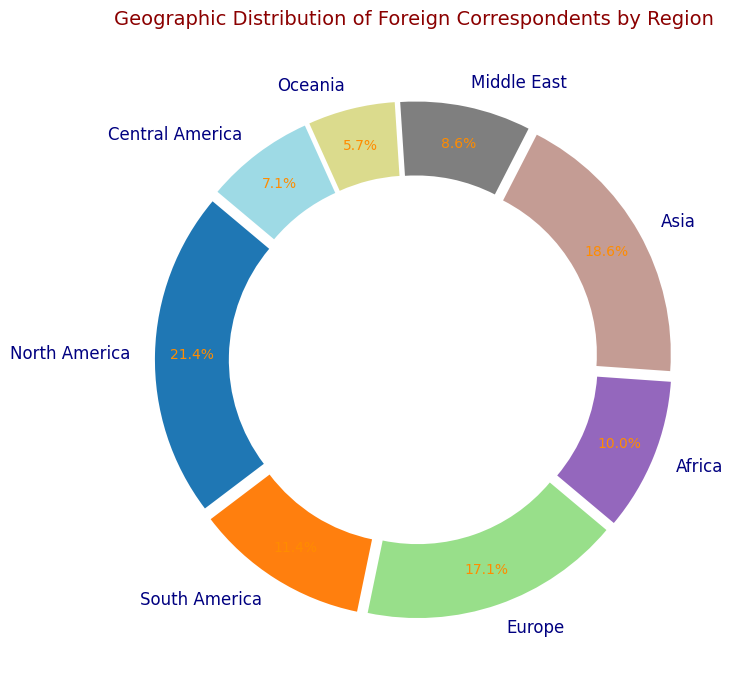What percentage of foreign correspondents are based in Asia? To determine the percentage, look for the label corresponding to Asia on the figure. Observe the percentage value displayed next to it.
Answer: 18.2% How many more foreign correspondents are there in North America compared to Africa? Find the numerical values of North America (150) and Africa (70) from the labels and subtract the number of correspondents in Africa from those in North America: 150 - 70 = 80.
Answer: 80 Which region has the lowest number of foreign correspondents? Identify the region with the smallest percentage or the smallest segment in the ring chart. Look for Oceania, which has the smallest share.
Answer: Oceania What is the combined percentage of foreign correspondents in Europe, Asia, and North America? Add the given percentages for Europe, Asia, and North America directly from the figure. Europe is 16.7%, Asia is 18.2%, and North America is 21.7%. The sum is 16.7% + 18.2% + 21.7% = 56.6%.
Answer: 56.6% What regions combined have more than 50% of the foreign correspondents? Identify and add the percentages until the sum exceeds 50%. North America (21.7%), Asia (18.2%), and Europe (16.7%) together equal 56.6%, which is more than 50%.
Answer: North America, Asia, and Europe Is the percentage of foreign correspondents in South America greater than in Central America and Oceania combined? Compare South America's percentage with the sum of Central America and Oceania. South America is 11.6%. Central America is 7.2%, and Oceania is 5.8%. 7.2% + 5.8% = 13%, which is more than 11.6%.
Answer: No Which region has a visually larger representation, Africa or the Middle East? Compare the segments visually in the figure. Africa has a segment representing 10.2%, while the Middle East has 8.8%. The segment for Africa appears larger.
Answer: Africa Rank the regions from the highest to the lowest number of foreign correspondents. Arrange the regions based on the number of correspondents presented in the figure and list them from highest to lowest. North America (21.7%), Asia (18.2%), Europe (16.7%), South America (11.6%), Africa (10.2%), the Middle East (8.8%), Central America (7.2%), and Oceania (5.8%).
Answer: North America, Asia, Europe, South America, Africa, the Middle East, Central America, Oceania What fraction of foreign correspondents are located in Oceania compared to North America? Find the ratio of the number of correspondents in Oceania (40) to those in North America (150). The fraction is 40/150, which simplifies to 4/15.
Answer: 4/15 What color represents Asia in the chart and why might this color choice matter? Identify the segment for Asia and describe its color. The segment is colored in a specific shade from the provided colormap, usually distinct among the others for easy visual differentiation. This helps viewers quickly recognize and distinguish the regions.
Answer: Varies (based on colormap and detailed in the figure) 